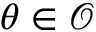Convert formula to latex. <formula><loc_0><loc_0><loc_500><loc_500>\theta \in { \mathcal { O } }</formula> 